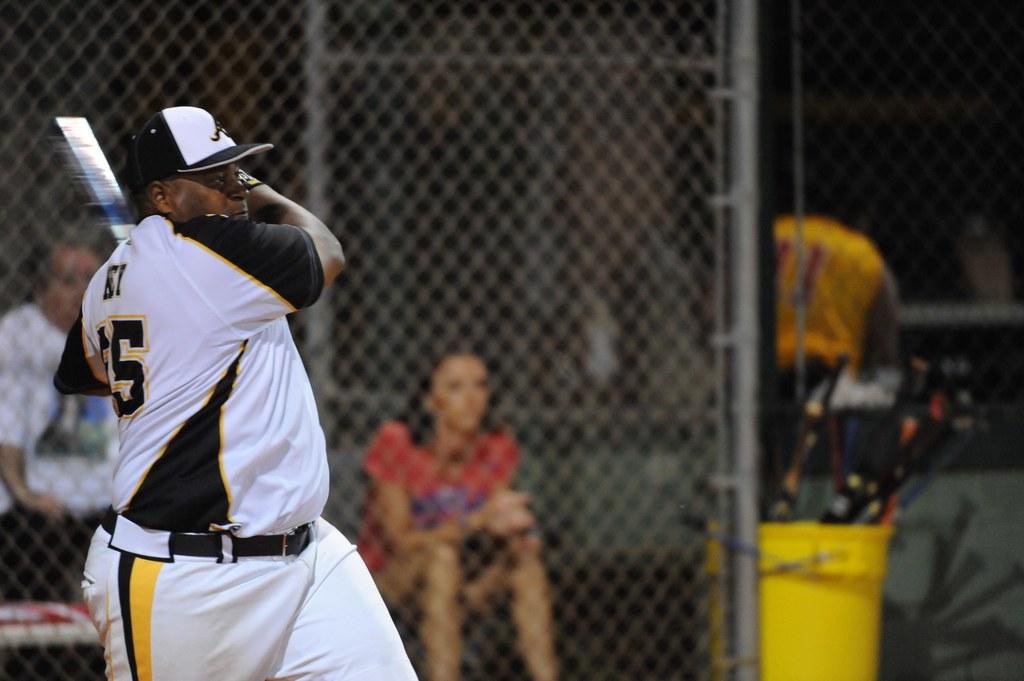What is the jersey number that you can see?
Offer a very short reply. 5. Is that 5 on the jersey of that player?
Keep it short and to the point. Yes. 